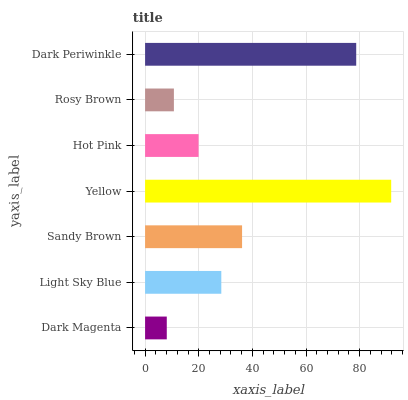Is Dark Magenta the minimum?
Answer yes or no. Yes. Is Yellow the maximum?
Answer yes or no. Yes. Is Light Sky Blue the minimum?
Answer yes or no. No. Is Light Sky Blue the maximum?
Answer yes or no. No. Is Light Sky Blue greater than Dark Magenta?
Answer yes or no. Yes. Is Dark Magenta less than Light Sky Blue?
Answer yes or no. Yes. Is Dark Magenta greater than Light Sky Blue?
Answer yes or no. No. Is Light Sky Blue less than Dark Magenta?
Answer yes or no. No. Is Light Sky Blue the high median?
Answer yes or no. Yes. Is Light Sky Blue the low median?
Answer yes or no. Yes. Is Rosy Brown the high median?
Answer yes or no. No. Is Rosy Brown the low median?
Answer yes or no. No. 